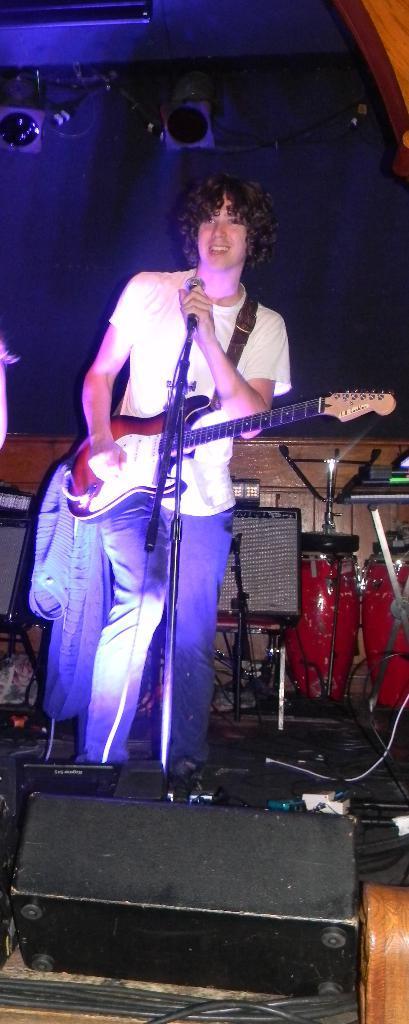Please provide a concise description of this image. In this picture we can see man holding guitar in his hand and playing it and singing on mic and in front of him we can see lights and at back of him we can see drums, wall, cloth. 